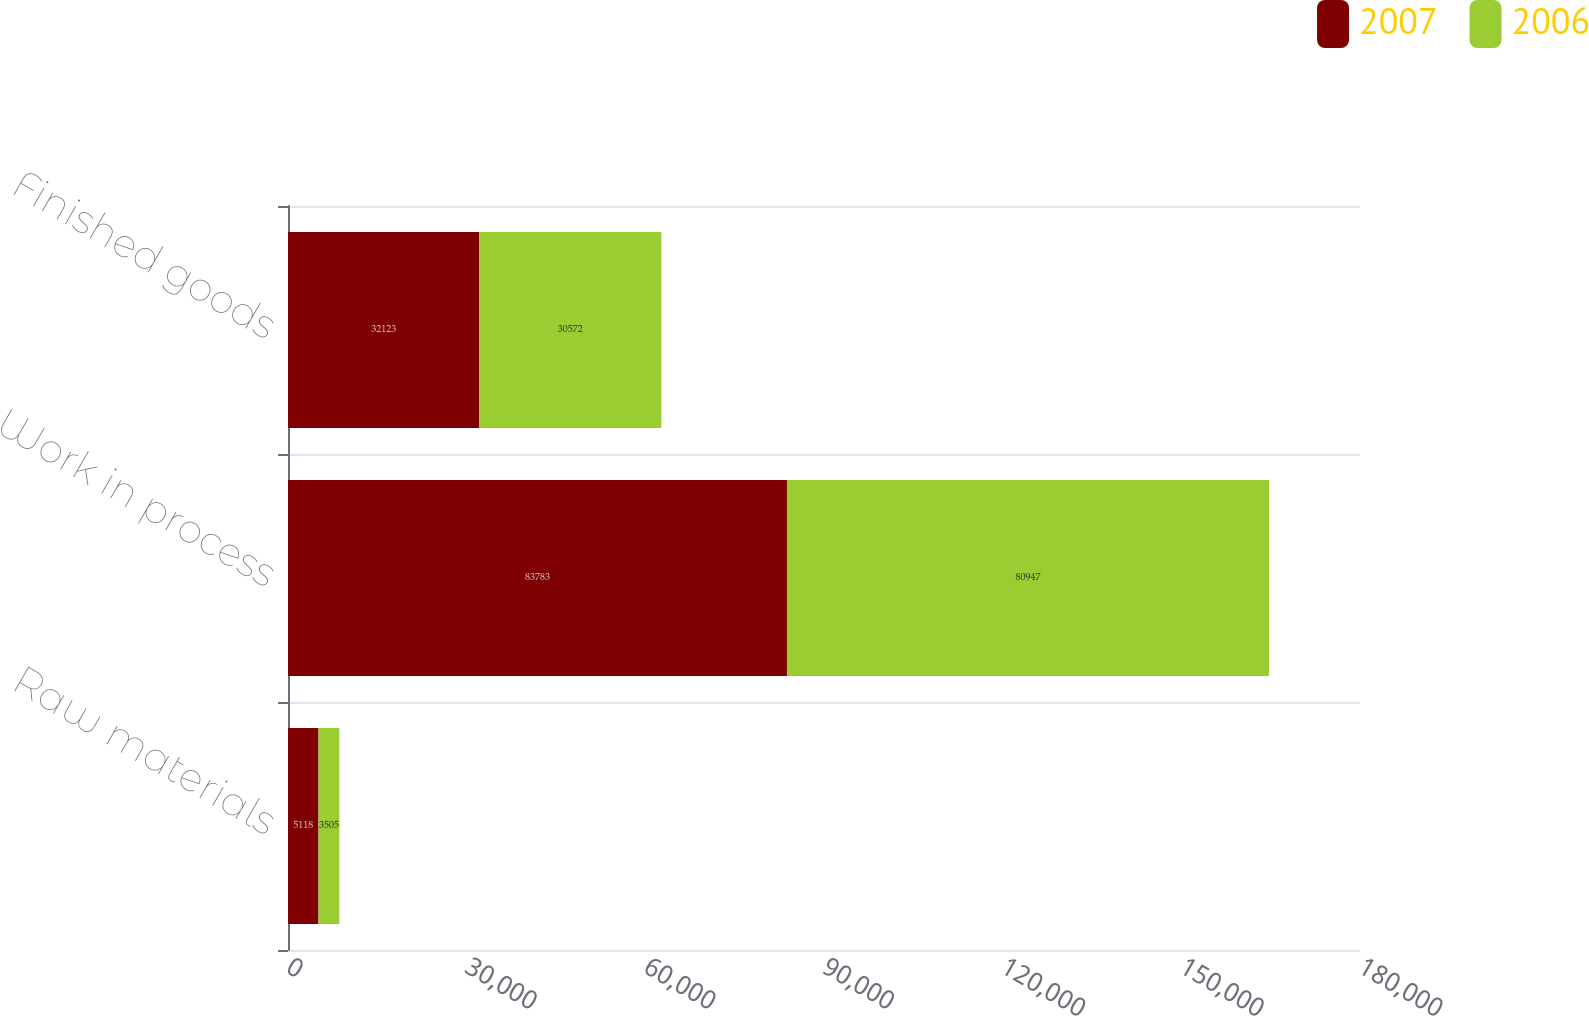Convert chart. <chart><loc_0><loc_0><loc_500><loc_500><stacked_bar_chart><ecel><fcel>Raw materials<fcel>Work in process<fcel>Finished goods<nl><fcel>2007<fcel>5118<fcel>83783<fcel>32123<nl><fcel>2006<fcel>3505<fcel>80947<fcel>30572<nl></chart> 